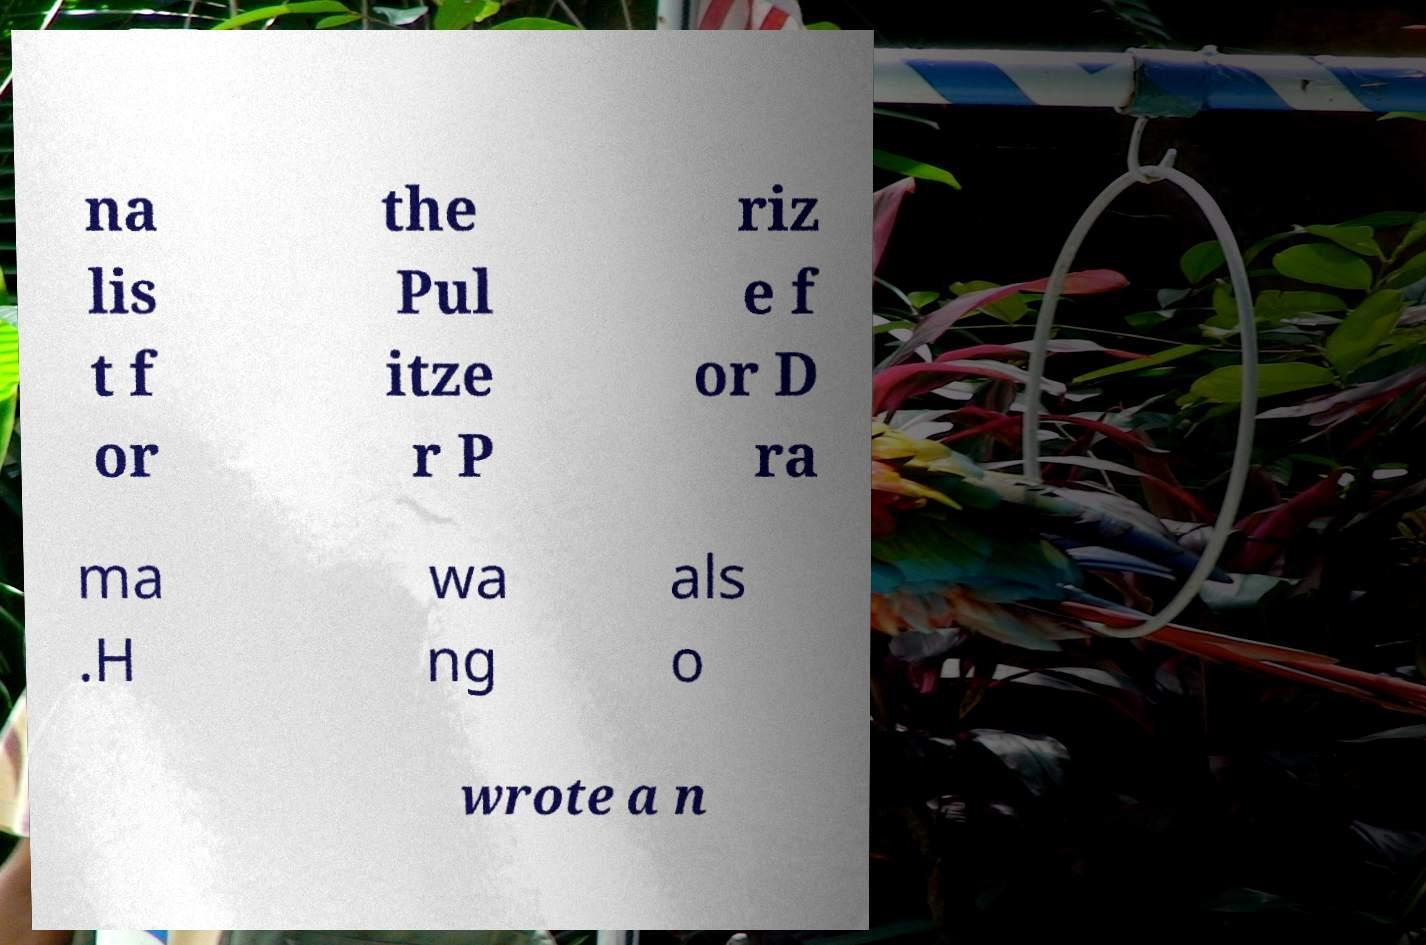Could you extract and type out the text from this image? na lis t f or the Pul itze r P riz e f or D ra ma .H wa ng als o wrote a n 